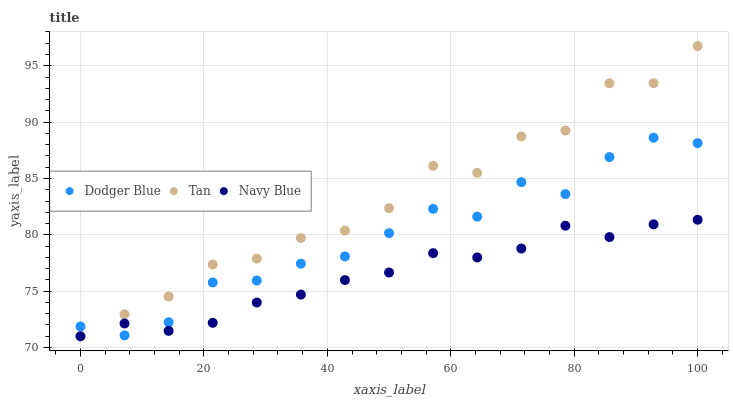Does Navy Blue have the minimum area under the curve?
Answer yes or no. Yes. Does Tan have the maximum area under the curve?
Answer yes or no. Yes. Does Dodger Blue have the minimum area under the curve?
Answer yes or no. No. Does Dodger Blue have the maximum area under the curve?
Answer yes or no. No. Is Navy Blue the smoothest?
Answer yes or no. Yes. Is Tan the roughest?
Answer yes or no. Yes. Is Dodger Blue the smoothest?
Answer yes or no. No. Is Dodger Blue the roughest?
Answer yes or no. No. Does Navy Blue have the lowest value?
Answer yes or no. Yes. Does Dodger Blue have the lowest value?
Answer yes or no. No. Does Tan have the highest value?
Answer yes or no. Yes. Does Dodger Blue have the highest value?
Answer yes or no. No. Does Tan intersect Navy Blue?
Answer yes or no. Yes. Is Tan less than Navy Blue?
Answer yes or no. No. Is Tan greater than Navy Blue?
Answer yes or no. No. 